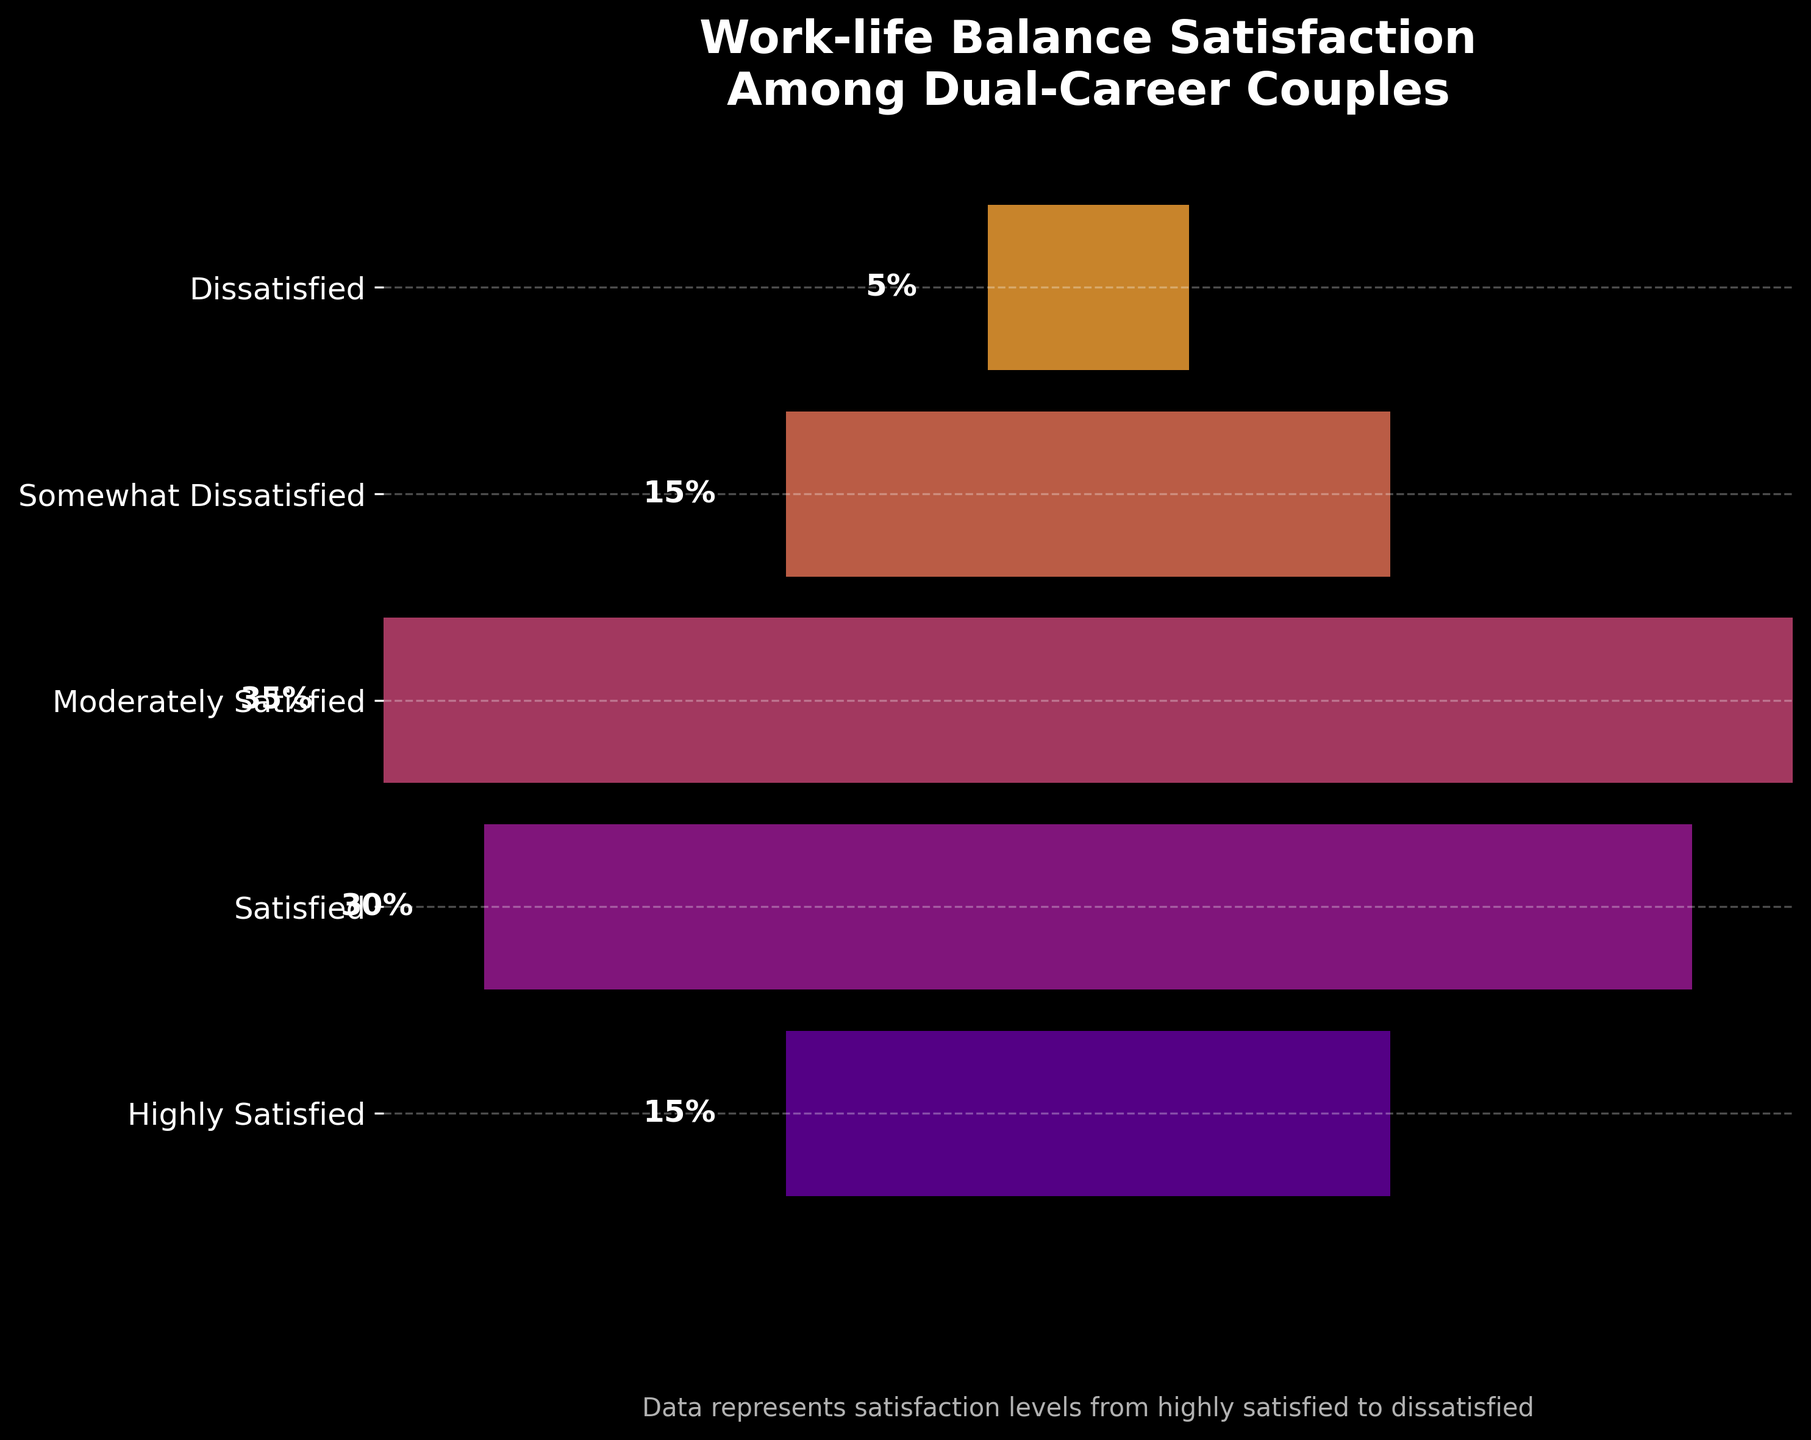What is the title of the funnel chart? The title is written at the top of the funnel chart in large, bold text. It states, "Work-life Balance Satisfaction Among Dual-Career Couples."
Answer: Work-life Balance Satisfaction Among Dual-Career Couples How many categories are represented in the chart? The chart displays different satisfaction levels, and each level is represented by a separate bar. By counting the bars, we find there are five categories.
Answer: Five Which satisfaction level has the highest percentage? By looking at the lengths of the bars and the percentage labels, the "Moderately Satisfied" category has the highest percentage, with a value of 35%.
Answer: Moderately Satisfied What is the combined percentage of couples who are either highly satisfied or satisfied? First, identify the percentages of the "Highly Satisfied" (15%) and "Satisfied" (30%) categories. Adding these together gives 15% + 30% = 45%.
Answer: 45% How does the percentage of "Dissatisfied" compare to that of "Highly Satisfied"? The bar for "Dissatisfied" is labeled 5%, and the bar for "Highly Satisfied" is labeled 15%. Thus, the "Dissatisfied" percentage (5%) is lower than the "Highly Satisfied" percentage (15%).
Answer: Lower Which category has a percentage exactly equal to the sum of percentages of "Highly Satisfied" and "Dissatisfied"? The "Highly Satisfied" percentage is 15% and the "Dissatisfied" percentage is 5%. Their sum is 15% + 5% = 20%. None of the categories on the chart have a percentage exactly equal to 20%.
Answer: None What is the median level of satisfaction? To find the median, list the percentages in ascending order: 5%, 15%, 15%, 30%, 35%. The median is the middle value, which is 15%.
Answer: 15% Between the "Satisfied" and the "Somewhat Dissatisfied" categories, which one has a lower percentage? The chart shows the "Satisfied" category with 30% and the "Somewhat Dissatisfied" category with 15%. Therefore, "Somewhat Dissatisfied" has a lower percentage.
Answer: Somewhat Dissatisfied If you combine the "Somewhat Dissatisfied" and "Dissatisfied" categories, what proportion of the couples does it represent? The percentages for "Somewhat Dissatisfied" and "Dissatisfied" are 15% and 5%, respectively. Adding them gives 15% + 5% = 20%.
Answer: 20% How does the "Moderately Satisfied" level compare to the "Highly Satisfied" level in terms of percentage difference? "Moderately Satisfied" has 35%, and "Highly Satisfied" has 15%. The difference is 35% - 15% = 20%.
Answer: 20% 